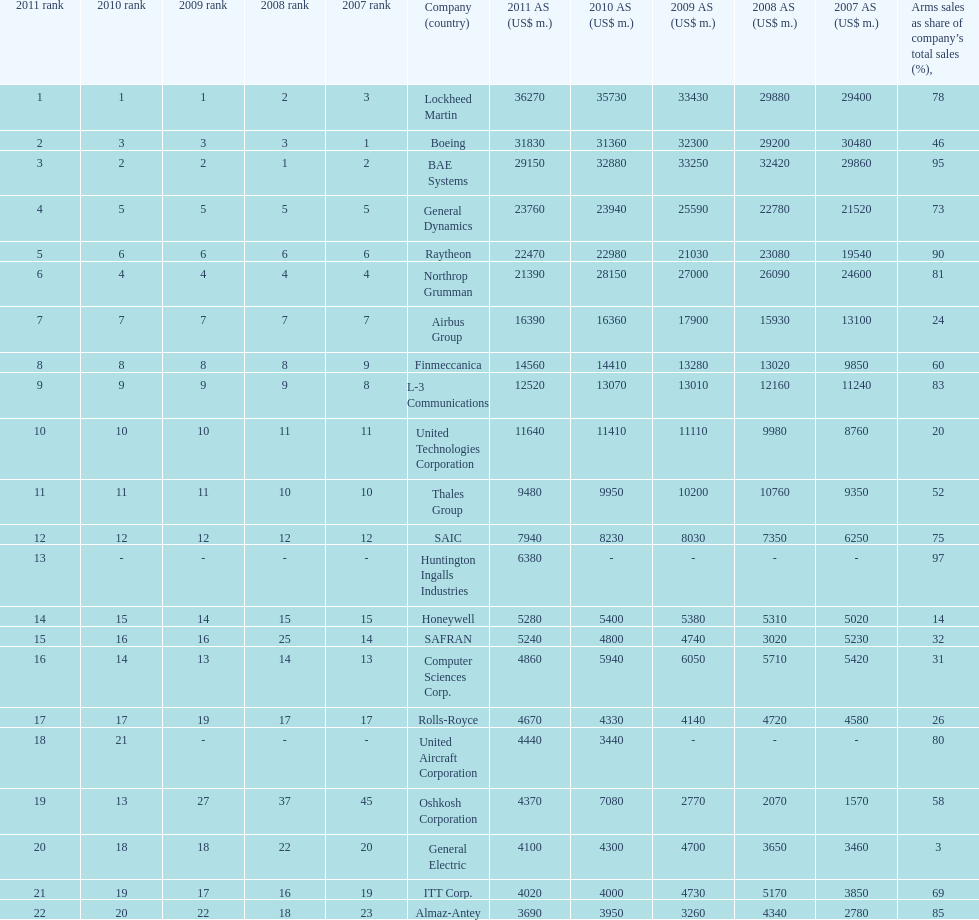Which company had the highest 2009 arms sales? Lockheed Martin. 